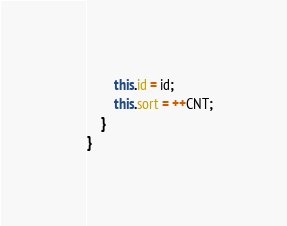<code> <loc_0><loc_0><loc_500><loc_500><_Java_>        this.id = id;
        this.sort = ++CNT;
    }
}
</code> 